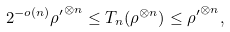Convert formula to latex. <formula><loc_0><loc_0><loc_500><loc_500>2 ^ { - o ( n ) } { \rho ^ { \prime } } ^ { \otimes n } \leq T _ { n } ( \rho ^ { \otimes n } ) \leq { \rho ^ { \prime } } ^ { \otimes n } ,</formula> 